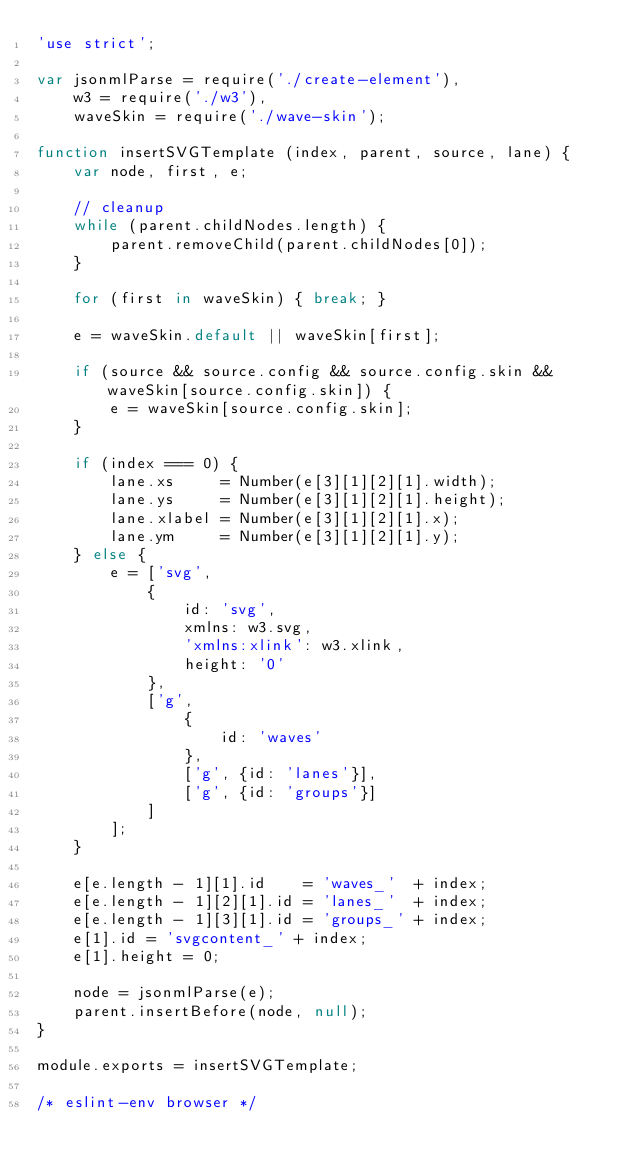<code> <loc_0><loc_0><loc_500><loc_500><_JavaScript_>'use strict';

var jsonmlParse = require('./create-element'),
    w3 = require('./w3'),
    waveSkin = require('./wave-skin');

function insertSVGTemplate (index, parent, source, lane) {
    var node, first, e;

    // cleanup
    while (parent.childNodes.length) {
        parent.removeChild(parent.childNodes[0]);
    }

    for (first in waveSkin) { break; }

    e = waveSkin.default || waveSkin[first];

    if (source && source.config && source.config.skin && waveSkin[source.config.skin]) {
        e = waveSkin[source.config.skin];
    }

    if (index === 0) {
        lane.xs     = Number(e[3][1][2][1].width);
        lane.ys     = Number(e[3][1][2][1].height);
        lane.xlabel = Number(e[3][1][2][1].x);
        lane.ym     = Number(e[3][1][2][1].y);
    } else {
        e = ['svg',
            {
                id: 'svg',
                xmlns: w3.svg,
                'xmlns:xlink': w3.xlink,
                height: '0'
            },
            ['g',
                {
                    id: 'waves'
                },
                ['g', {id: 'lanes'}],
                ['g', {id: 'groups'}]
            ]
        ];
    }

    e[e.length - 1][1].id    = 'waves_'  + index;
    e[e.length - 1][2][1].id = 'lanes_'  + index;
    e[e.length - 1][3][1].id = 'groups_' + index;
    e[1].id = 'svgcontent_' + index;
    e[1].height = 0;

    node = jsonmlParse(e);
    parent.insertBefore(node, null);
}

module.exports = insertSVGTemplate;

/* eslint-env browser */
</code> 